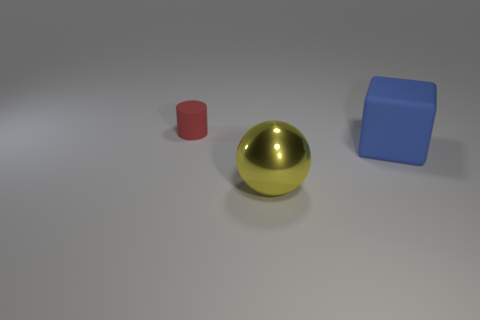Are there an equal number of things that are in front of the cylinder and matte cylinders?
Your answer should be very brief. No. What number of large objects are both in front of the large matte cube and behind the ball?
Give a very brief answer. 0. What size is the blue object that is made of the same material as the tiny red thing?
Offer a very short reply. Large. Are there more big things that are behind the large yellow shiny thing than brown things?
Offer a very short reply. Yes. What is the shape of the thing that is to the left of the large blue cube and to the right of the tiny object?
Provide a short and direct response. Sphere. Do the red rubber cylinder and the cube have the same size?
Your answer should be compact. No. There is a big cube; what number of small red rubber objects are on the left side of it?
Provide a succinct answer. 1. Are there an equal number of tiny matte things that are right of the yellow sphere and big rubber cubes in front of the red cylinder?
Offer a very short reply. No. There is a large object right of the ball; is its shape the same as the red matte object?
Make the answer very short. No. Is there anything else that has the same material as the sphere?
Ensure brevity in your answer.  No. 